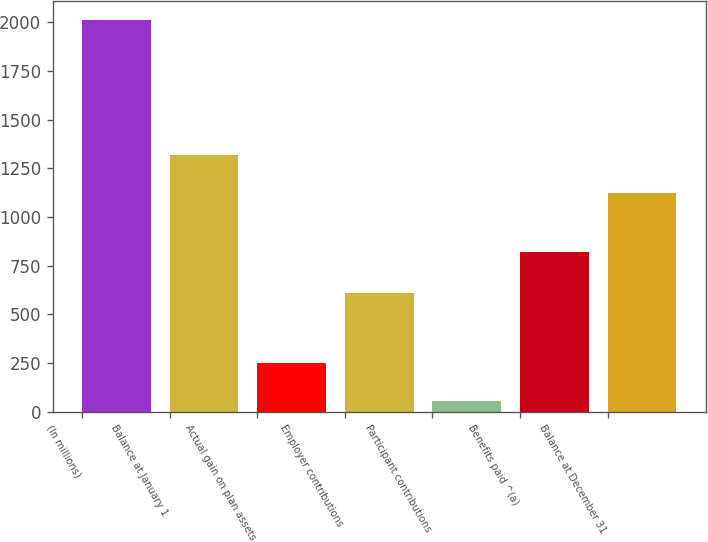Convert chart. <chart><loc_0><loc_0><loc_500><loc_500><bar_chart><fcel>(In millions)<fcel>Balance at January 1<fcel>Actual gain on plan assets<fcel>Employer contributions<fcel>Participant contributions<fcel>Benefits paid ^(a)<fcel>Balance at December 31<nl><fcel>2010<fcel>1320.5<fcel>250.5<fcel>611<fcel>55<fcel>818<fcel>1125<nl></chart> 